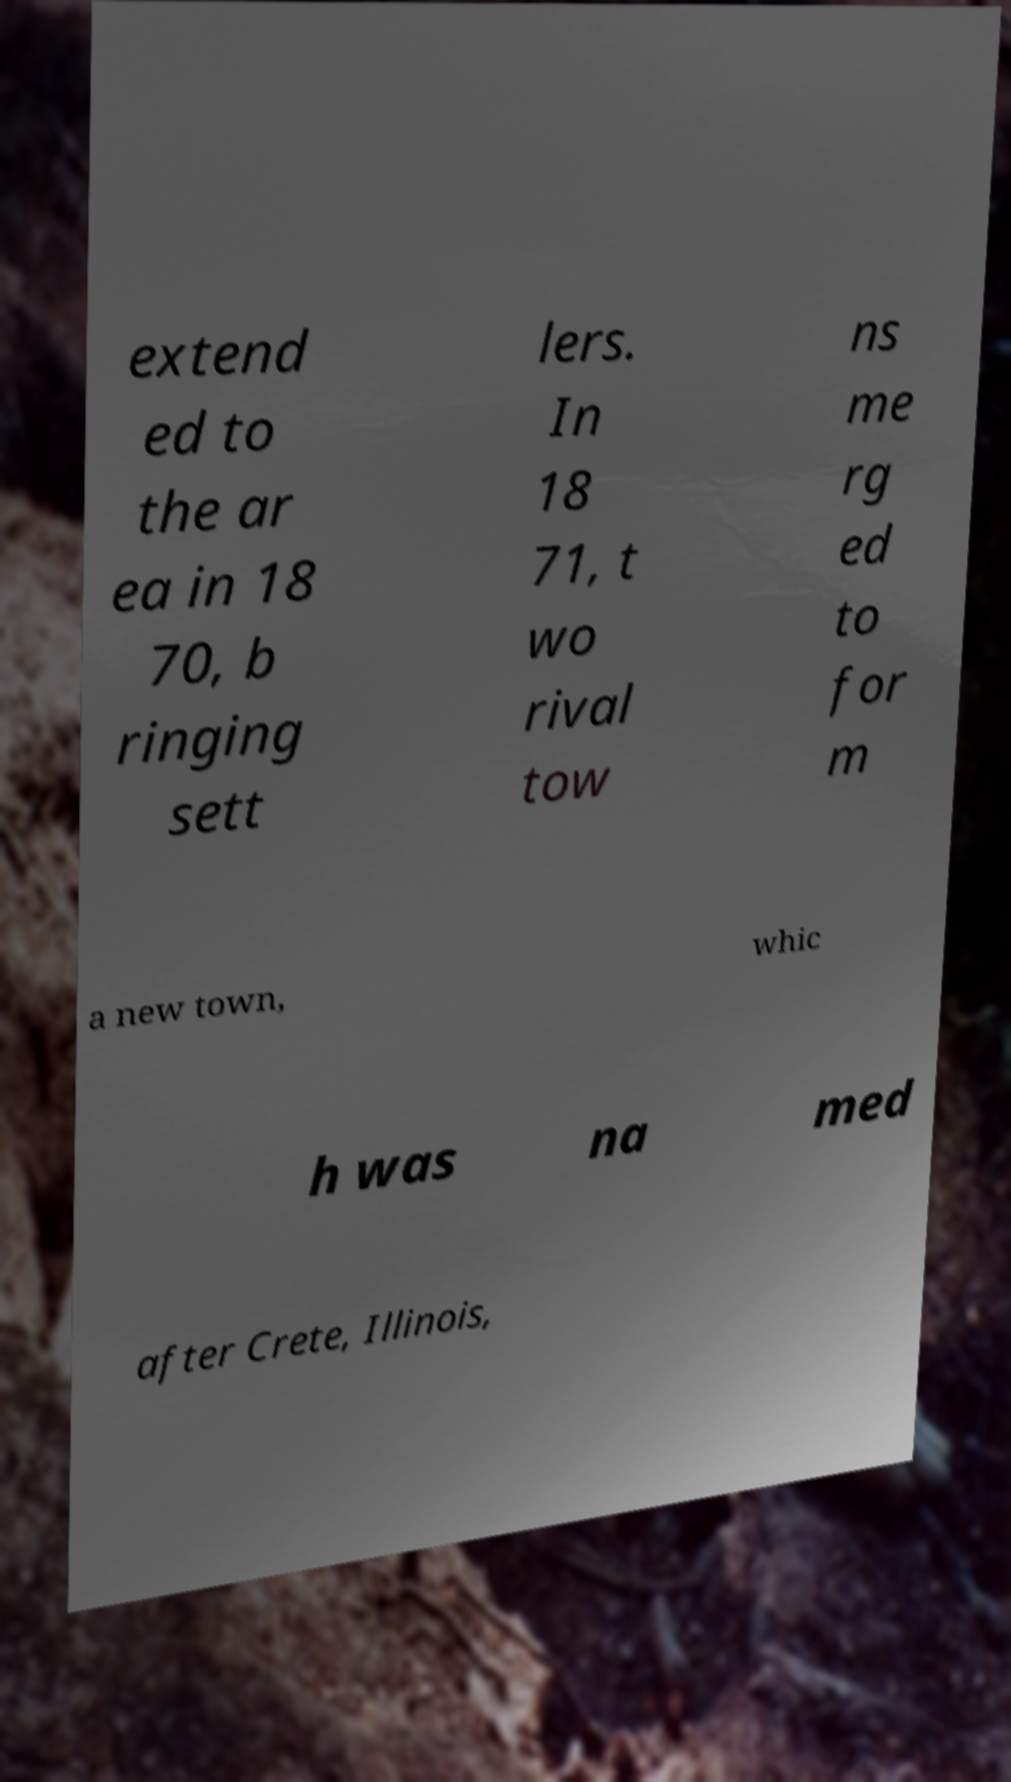Could you assist in decoding the text presented in this image and type it out clearly? extend ed to the ar ea in 18 70, b ringing sett lers. In 18 71, t wo rival tow ns me rg ed to for m a new town, whic h was na med after Crete, Illinois, 